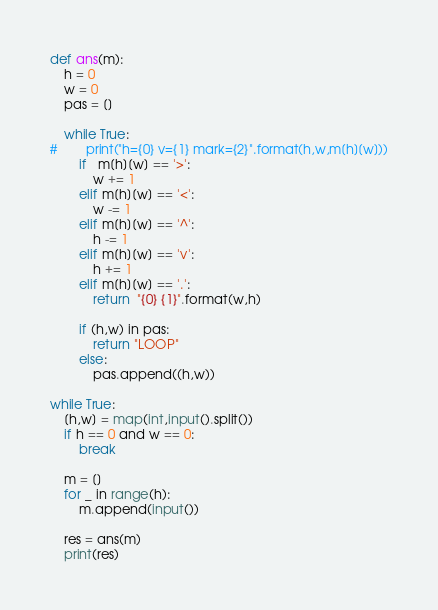Convert code to text. <code><loc_0><loc_0><loc_500><loc_500><_Python_>def ans(m):
    h = 0
    w = 0
    pas = []

    while True:
#        print("h={0} v={1} mark={2}".format(h,w,m[h][w]))
        if   m[h][w] == '>':
            w += 1
        elif m[h][w] == '<':
            w -= 1
        elif m[h][w] == '^':
            h -= 1
        elif m[h][w] == 'v':
            h += 1
        elif m[h][w] == '.':
            return  "{0} {1}".format(w,h)

        if (h,w) in pas:
            return "LOOP"
        else:
            pas.append((h,w))

while True:
    [h,w] = map(int,input().split())
    if h == 0 and w == 0:
        break

    m = []
    for _ in range(h):
        m.append(input())

    res = ans(m)
    print(res)</code> 